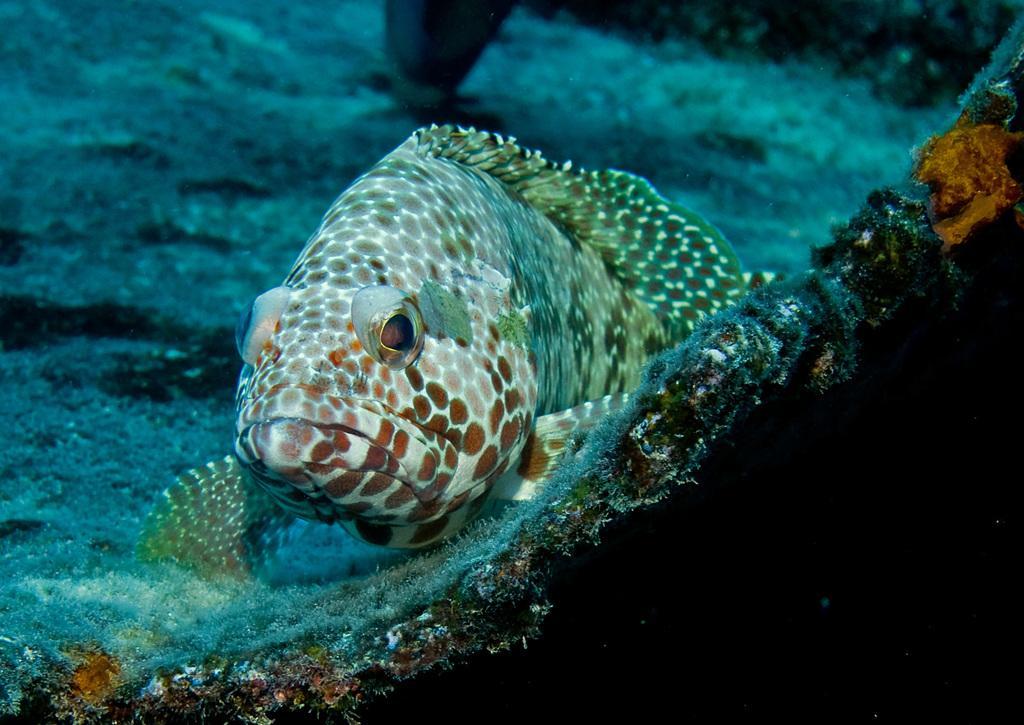Describe this image in one or two sentences. In this image there is a fish in the water , and in the background there are reefs. 